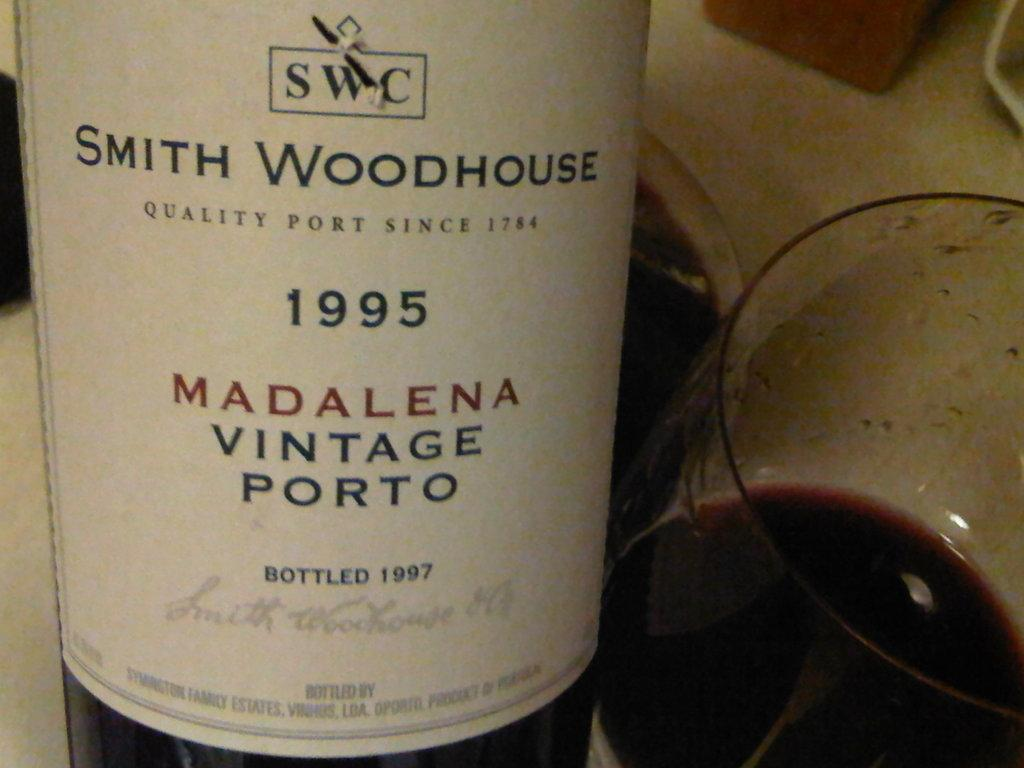<image>
Give a short and clear explanation of the subsequent image. A bottle of wine with a white label and Smith Woodhouse on the label. 